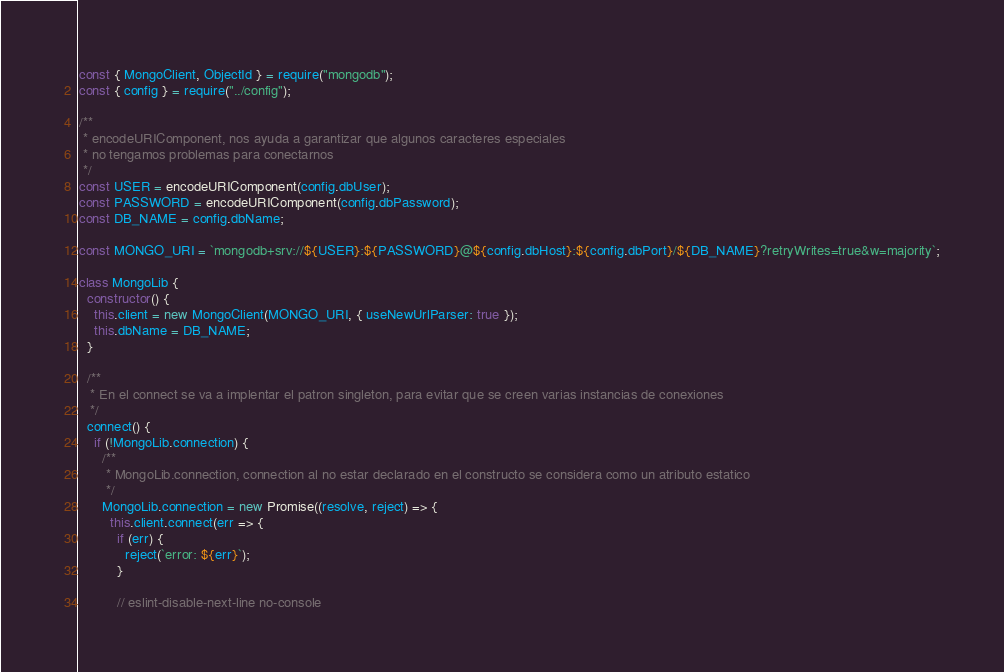<code> <loc_0><loc_0><loc_500><loc_500><_JavaScript_>const { MongoClient, ObjectId } = require("mongodb");
const { config } = require("../config");

/**
 * encodeURIComponent, nos ayuda a garantizar que algunos caracteres especiales
 * no tengamos problemas para conectarnos
 */
const USER = encodeURIComponent(config.dbUser);
const PASSWORD = encodeURIComponent(config.dbPassword);
const DB_NAME = config.dbName;

const MONGO_URI = `mongodb+srv://${USER}:${PASSWORD}@${config.dbHost}:${config.dbPort}/${DB_NAME}?retryWrites=true&w=majority`;

class MongoLib {
  constructor() {
    this.client = new MongoClient(MONGO_URI, { useNewUrlParser: true });
    this.dbName = DB_NAME;
  }

  /**
   * En el connect se va a implentar el patron singleton, para evitar que se creen varias instancias de conexiones
   */
  connect() {
    if (!MongoLib.connection) {
      /**
       * MongoLib.connection, connection al no estar declarado en el constructo se considera como un atributo estatico
       */
      MongoLib.connection = new Promise((resolve, reject) => {
        this.client.connect(err => {
          if (err) {
            reject(`error: ${err}`);
          }

          // eslint-disable-next-line no-console</code> 